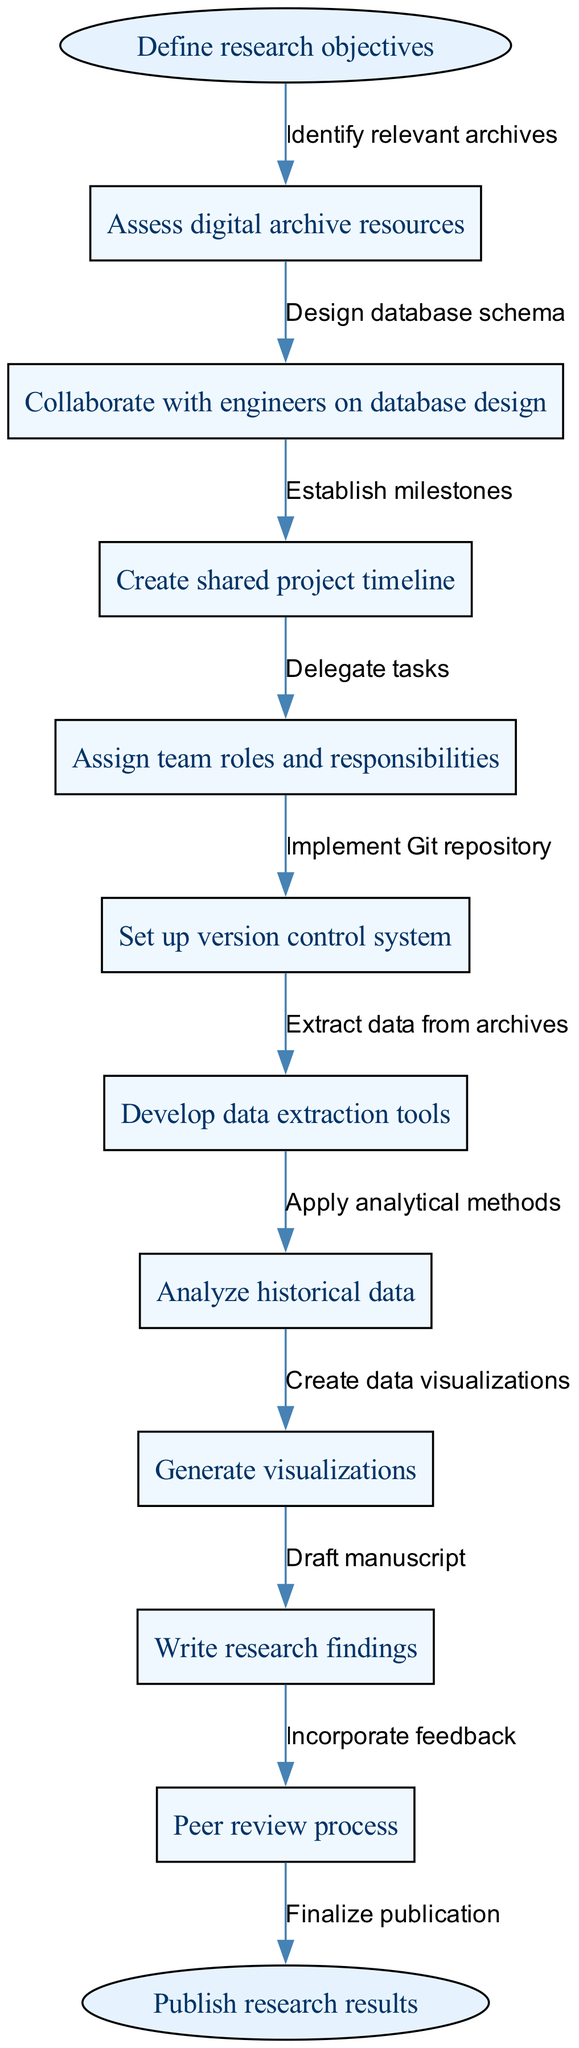What is the starting node of the diagram? The starting node, representing the first step in the flow, is labeled "Define research objectives." This is directly stated in the diagram as the first element before any other nodes.
Answer: Define research objectives How many nodes are present in the diagram? To answer this, count all the individual nodes listed in the provided data, which includes the start and end nodes as well as the intermediate nodes. There are a total of 10 nodes in the diagram.
Answer: 10 What is the final action in the workflow? The last node, which is linked directly from the previous node, indicates the final action in the diagram. This node is labeled "Publish research results."
Answer: Publish research results What is the connection between the nodes "Analyze historical data" and "Write research findings"? The two nodes are sequentially connected by one edge, which indicates the process that follows analyzing data to producing findings. The edge represents the workflow step as "Draft manuscript."
Answer: Draft manuscript Which task comes immediately after "Set up version control system"? To find this, look at the positioning of the nodes. The node "Set up version control system" is connected to the next node, which is "Develop data extraction tools." This shows the immediate next step in the project management flow.
Answer: Develop data extraction tools What role do engineers play in the research project? Engineers are involved in the node labeled "Collaborate with engineers on database design," indicating their contribution to the database aspect of the research project. This point shows their integration in refining technical components.
Answer: Database design Which milestone follows the "Create shared project timeline"? From the flow of tasks, the node "Establish milestones" directly follows "Create shared project timeline." This signifies the next significant step where specific goals are set within the collaborative effort.
Answer: Establish milestones What is an essential tool mentioned for managing the project? The node "Set up version control system" indicates that utilizing version control systems is essential for managing collaboration and tracking changes within the project. This tool is critical in collaborative settings for efficient handling of documents and coding.
Answer: Version control system 